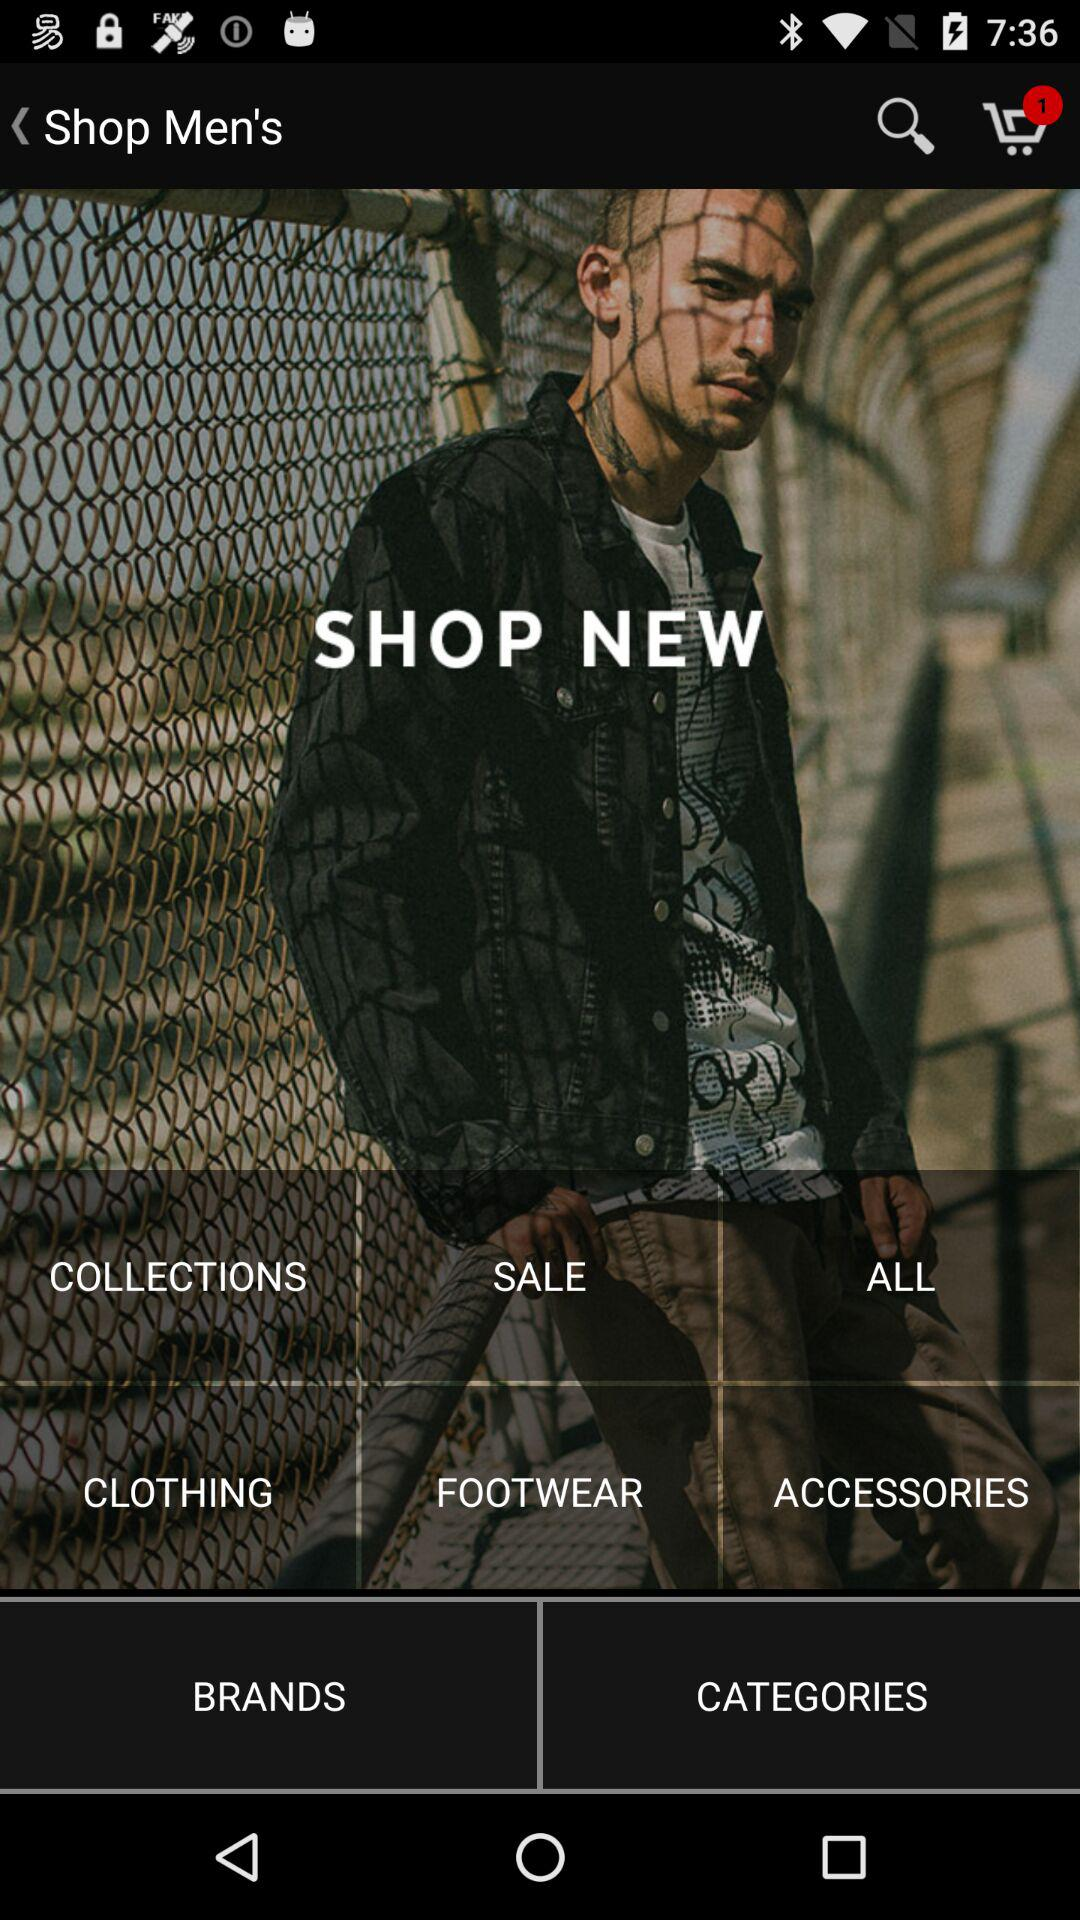How many products are in the cart? There is one product in the cart. 